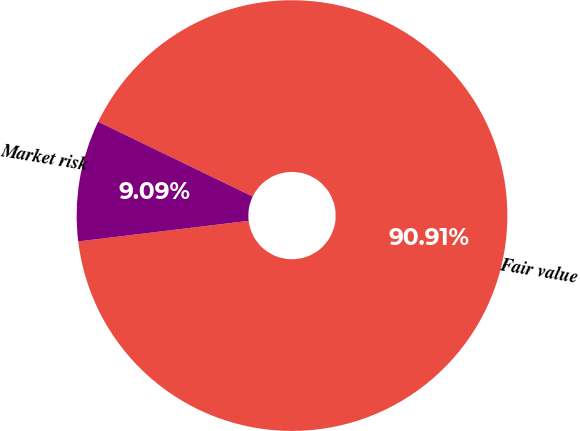<chart> <loc_0><loc_0><loc_500><loc_500><pie_chart><fcel>Fair value<fcel>Market risk<nl><fcel>90.91%<fcel>9.09%<nl></chart> 